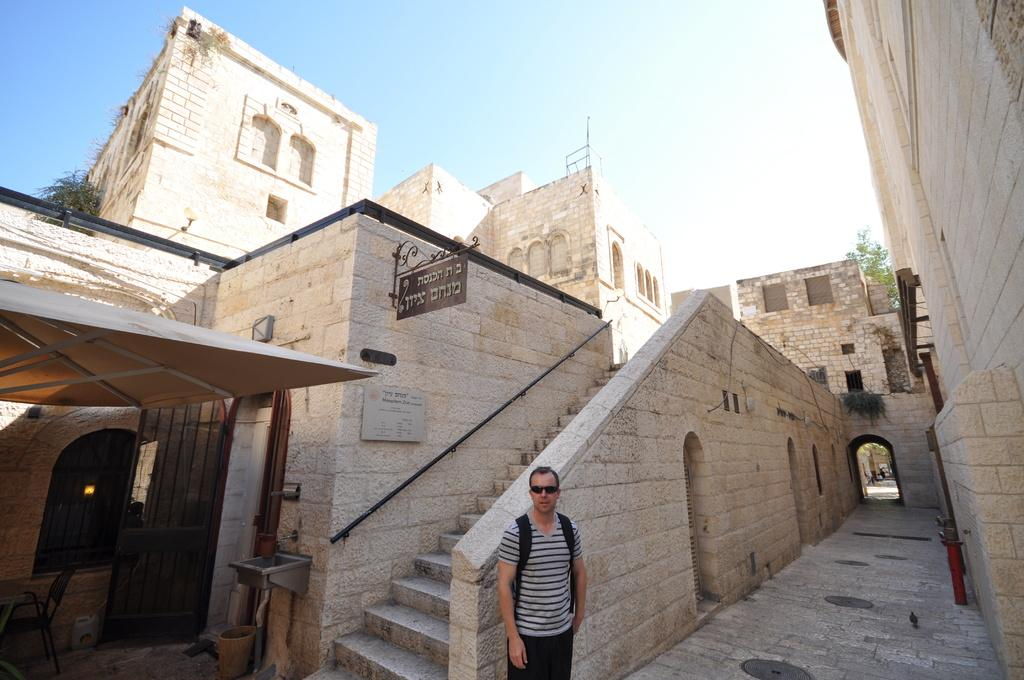What is the main subject in the foreground of the image? There is a man standing in the foreground of the image. What can be seen behind the man in the image? There is an architecture visible behind the man. What month is it in the image? The month cannot be determined from the image, as there is no information about the time of year or any seasonal indicators present. 